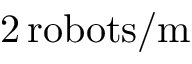<formula> <loc_0><loc_0><loc_500><loc_500>2 \, r o b o t s / m</formula> 